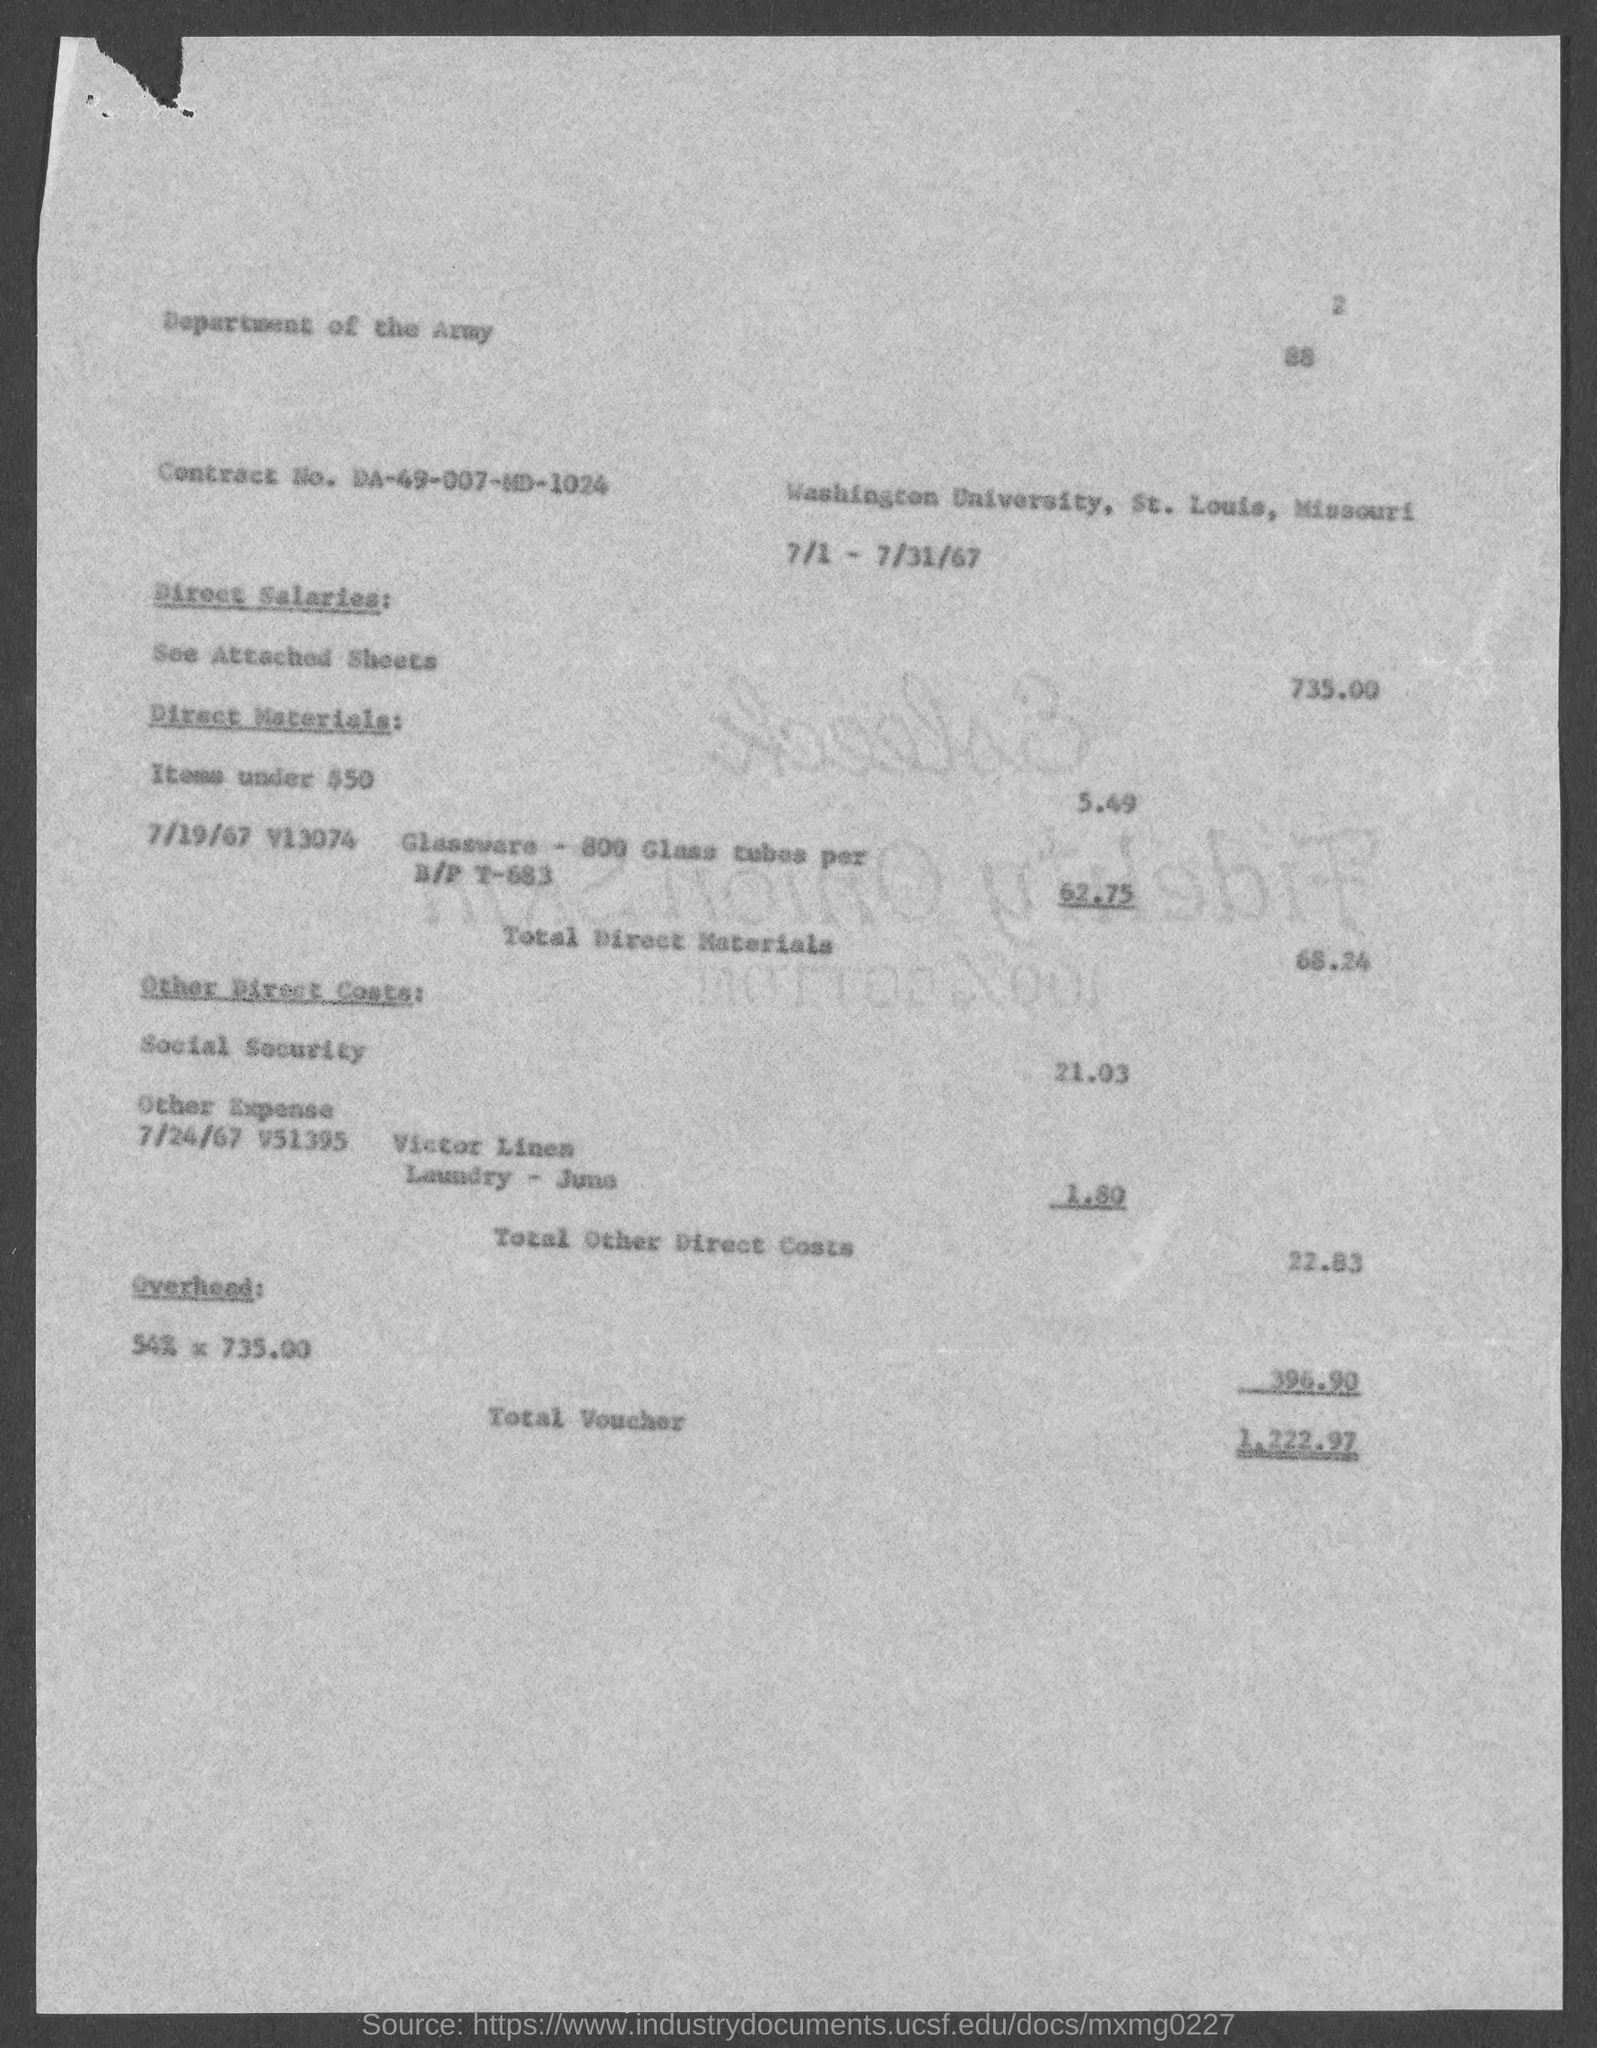List a handful of essential elements in this visual. The Contract No. given in the document is DA-49-007-MD-1024. The direct salaries cost mentioned in the document is 735.00. The total voucher amount mentioned in the document is 1,222.97. 